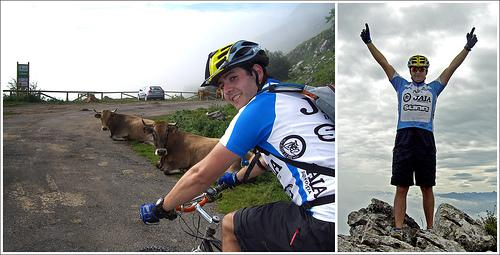Question: what is on the ground?
Choices:
A. Elephants.
B. Girrafes.
C. Sheeps.
D. Cows.
Answer with the letter. Answer: D Question: who is riding the bike?
Choices:
A. A man.
B. A woman.
C. A boy.
D. A girl.
Answer with the letter. Answer: A Question: why are his hands raised?
Choices:
A. Celebrating.
B. Following police commands.
C. Pointing at something.
D. In despair.
Answer with the letter. Answer: A Question: when is the man standing?
Choices:
A. On a table.
B. On a bench.
C. On the sidewalk.
D. On rocks.
Answer with the letter. Answer: D 